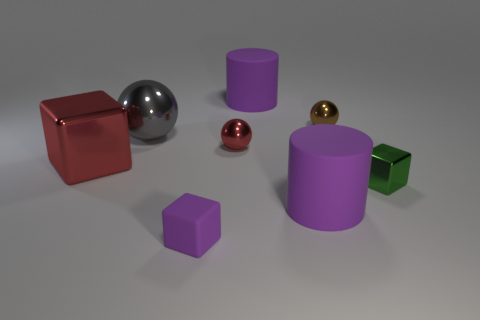Does the cube on the right side of the small red thing have the same material as the red thing behind the big red block?
Offer a very short reply. Yes. What number of metal objects are either big cubes or tiny things?
Offer a terse response. 4. There is a large purple thing in front of the cube behind the cube on the right side of the brown ball; what is it made of?
Your answer should be very brief. Rubber. There is a purple thing that is behind the tiny green shiny cube; is its shape the same as the big rubber thing that is in front of the gray thing?
Keep it short and to the point. Yes. What is the color of the small shiny thing to the left of the big purple cylinder in front of the tiny brown shiny thing?
Your answer should be very brief. Red. What number of blocks are either blue metallic things or green metallic things?
Provide a succinct answer. 1. What number of purple things are behind the small sphere that is on the right side of the purple rubber cylinder that is in front of the brown sphere?
Your answer should be very brief. 1. Are there any red spheres made of the same material as the small brown thing?
Offer a very short reply. Yes. Are the green object and the purple cube made of the same material?
Offer a terse response. No. What number of big things are on the left side of the small cube behind the small rubber block?
Your response must be concise. 4. 